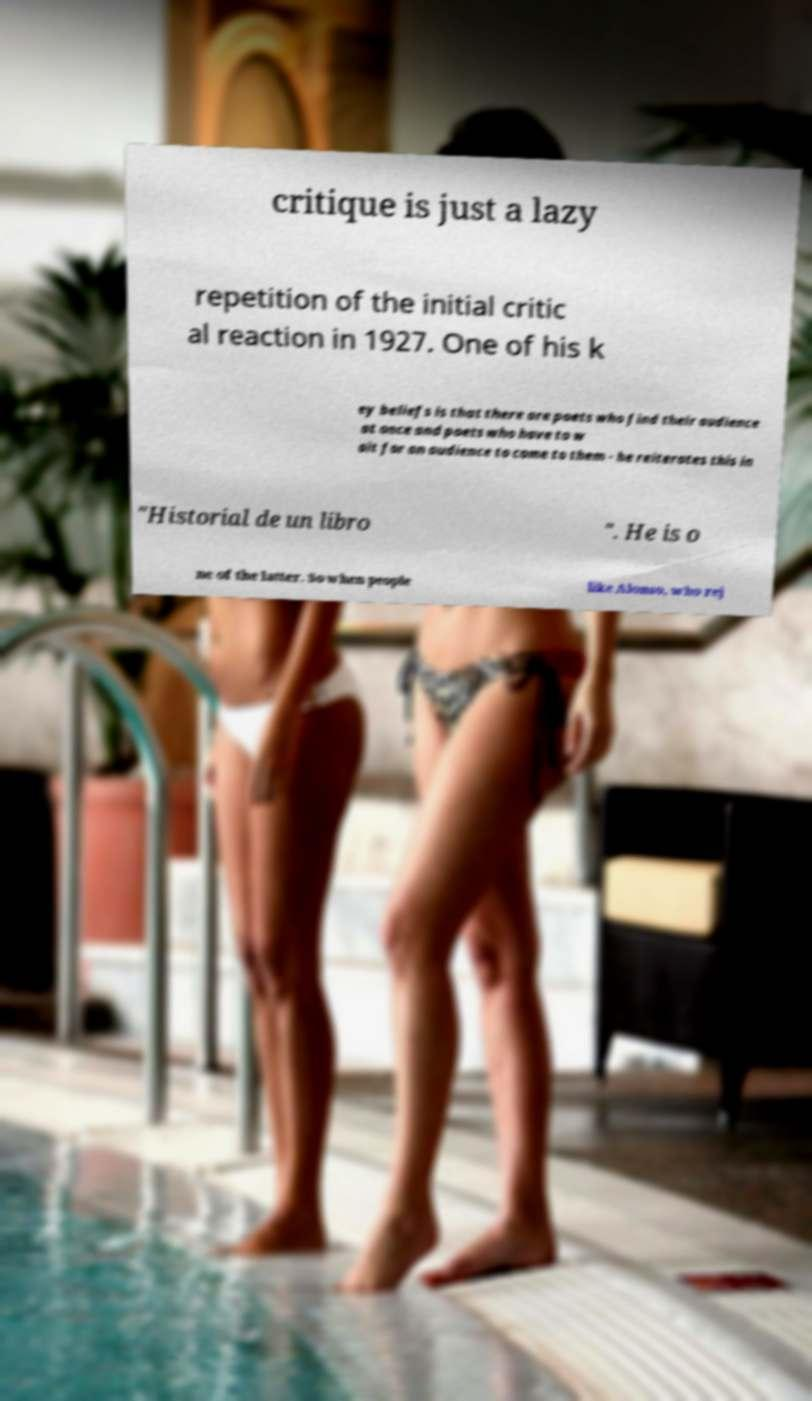Can you read and provide the text displayed in the image?This photo seems to have some interesting text. Can you extract and type it out for me? critique is just a lazy repetition of the initial critic al reaction in 1927. One of his k ey beliefs is that there are poets who find their audience at once and poets who have to w ait for an audience to come to them - he reiterates this in "Historial de un libro ". He is o ne of the latter. So when people like Alonso, who rej 